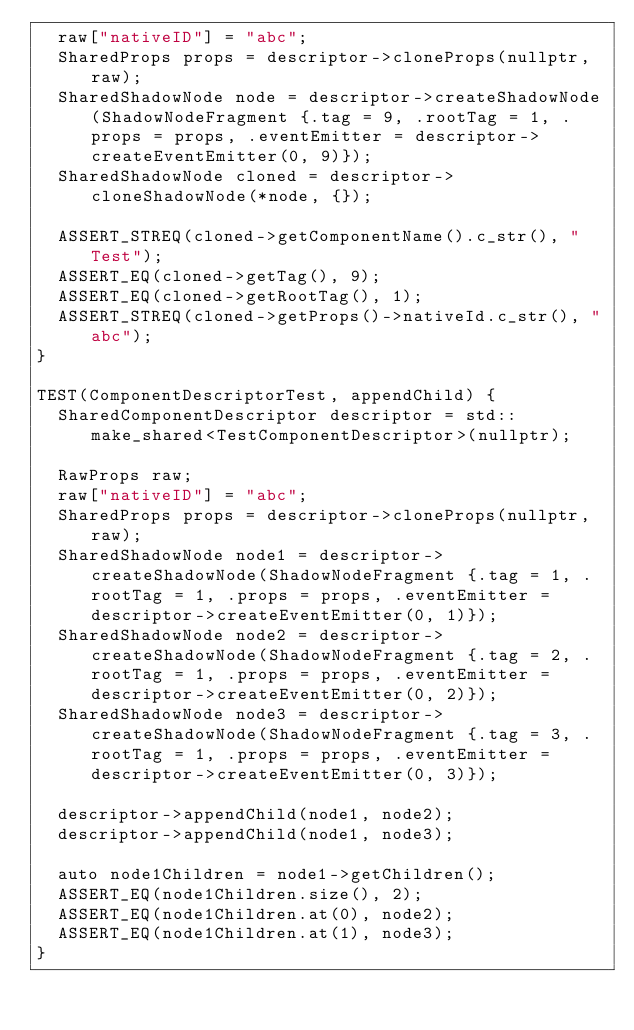<code> <loc_0><loc_0><loc_500><loc_500><_C++_>  raw["nativeID"] = "abc";
  SharedProps props = descriptor->cloneProps(nullptr, raw);
  SharedShadowNode node = descriptor->createShadowNode(ShadowNodeFragment {.tag = 9, .rootTag = 1, .props = props, .eventEmitter = descriptor->createEventEmitter(0, 9)});
  SharedShadowNode cloned = descriptor->cloneShadowNode(*node, {});

  ASSERT_STREQ(cloned->getComponentName().c_str(), "Test");
  ASSERT_EQ(cloned->getTag(), 9);
  ASSERT_EQ(cloned->getRootTag(), 1);
  ASSERT_STREQ(cloned->getProps()->nativeId.c_str(), "abc");
}

TEST(ComponentDescriptorTest, appendChild) {
  SharedComponentDescriptor descriptor = std::make_shared<TestComponentDescriptor>(nullptr);

  RawProps raw;
  raw["nativeID"] = "abc";
  SharedProps props = descriptor->cloneProps(nullptr, raw);
  SharedShadowNode node1 = descriptor->createShadowNode(ShadowNodeFragment {.tag = 1, .rootTag = 1, .props = props, .eventEmitter = descriptor->createEventEmitter(0, 1)});
  SharedShadowNode node2 = descriptor->createShadowNode(ShadowNodeFragment {.tag = 2, .rootTag = 1, .props = props, .eventEmitter = descriptor->createEventEmitter(0, 2)});
  SharedShadowNode node3 = descriptor->createShadowNode(ShadowNodeFragment {.tag = 3, .rootTag = 1, .props = props, .eventEmitter = descriptor->createEventEmitter(0, 3)});

  descriptor->appendChild(node1, node2);
  descriptor->appendChild(node1, node3);

  auto node1Children = node1->getChildren();
  ASSERT_EQ(node1Children.size(), 2);
  ASSERT_EQ(node1Children.at(0), node2);
  ASSERT_EQ(node1Children.at(1), node3);
}
</code> 